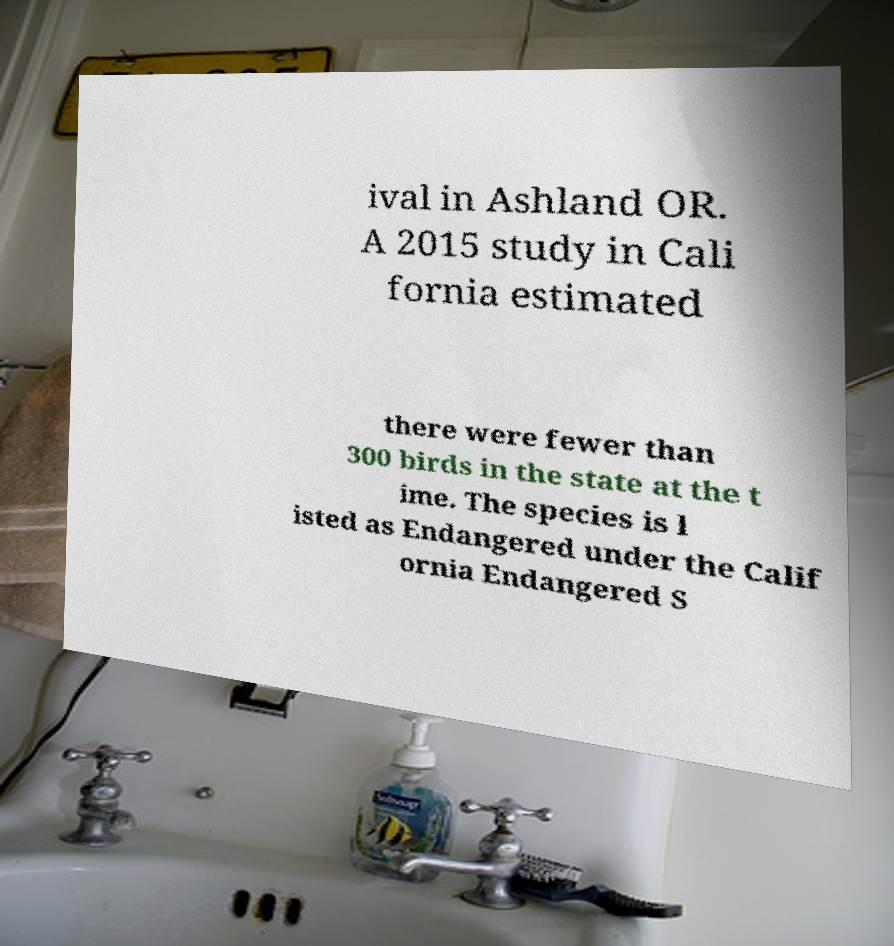Can you read and provide the text displayed in the image?This photo seems to have some interesting text. Can you extract and type it out for me? ival in Ashland OR. A 2015 study in Cali fornia estimated there were fewer than 300 birds in the state at the t ime. The species is l isted as Endangered under the Calif ornia Endangered S 